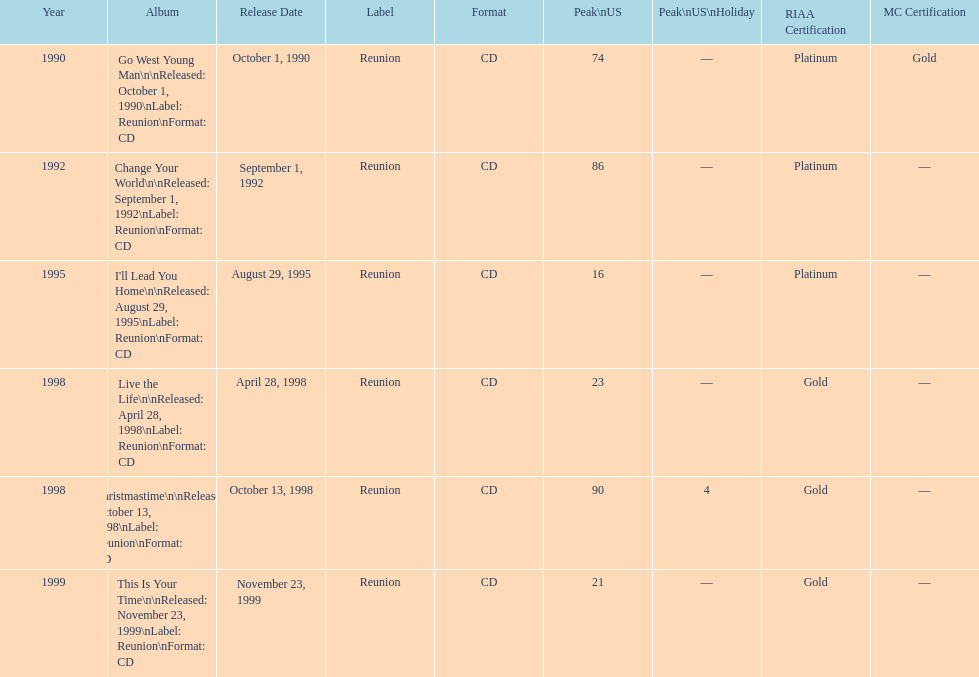Parse the table in full. {'header': ['Year', 'Album', 'Release Date', 'Label', 'Format', 'Peak\\nUS', 'Peak\\nUS\\nHoliday', 'RIAA Certification', 'MC Certification'], 'rows': [['1990', 'Go West Young Man\\n\\nReleased: October 1, 1990\\nLabel: Reunion\\nFormat: CD', 'October 1, 1990', 'Reunion', 'CD', '74', '—', 'Platinum', 'Gold'], ['1992', 'Change Your World\\n\\nReleased: September 1, 1992\\nLabel: Reunion\\nFormat: CD', 'September 1, 1992', 'Reunion', 'CD', '86', '—', 'Platinum', '—'], ['1995', "I'll Lead You Home\\n\\nReleased: August 29, 1995\\nLabel: Reunion\\nFormat: CD", 'August 29, 1995', 'Reunion', 'CD', '16', '—', 'Platinum', '—'], ['1998', 'Live the Life\\n\\nReleased: April 28, 1998\\nLabel: Reunion\\nFormat: CD', 'April 28, 1998', 'Reunion', 'CD', '23', '—', 'Gold', '—'], ['1998', 'Christmastime\\n\\nReleased: October 13, 1998\\nLabel: Reunion\\nFormat: CD', 'October 13, 1998', 'Reunion', 'CD', '90', '4', 'Gold', '—'], ['1999', 'This Is Your Time\\n\\nReleased: November 23, 1999\\nLabel: Reunion\\nFormat: CD', 'November 23, 1999', 'Reunion', 'CD', '21', '—', 'Gold', '—']]} What year comes after 1995? 1998. 